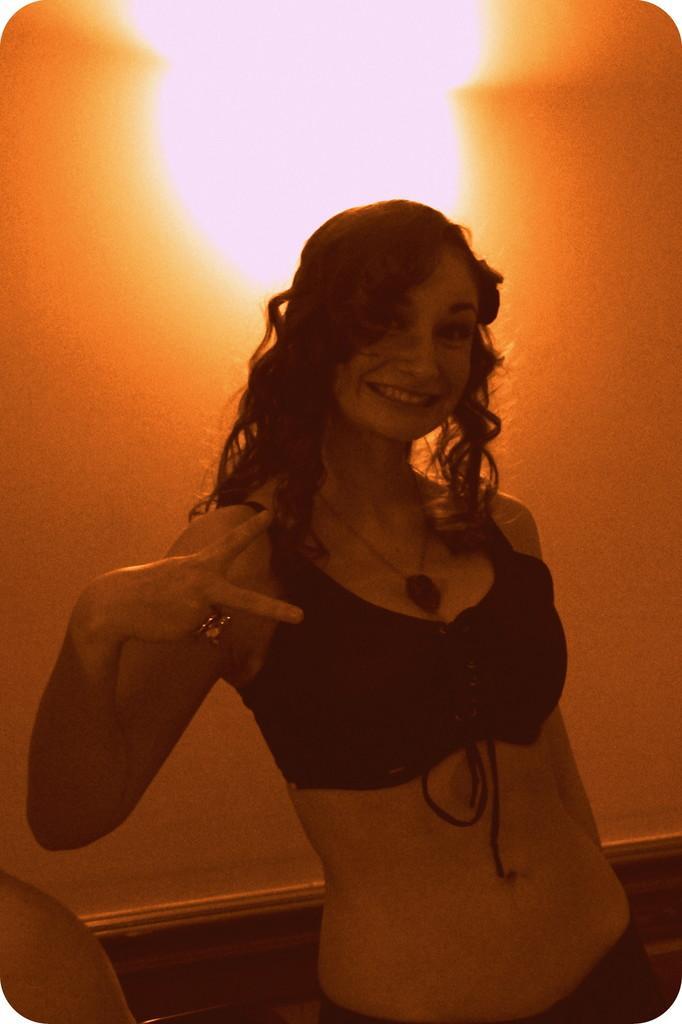Can you describe this image briefly? There is a woman in black color bikini smiling, standing and showing a symbol. In the background, there is a light near the wall. 